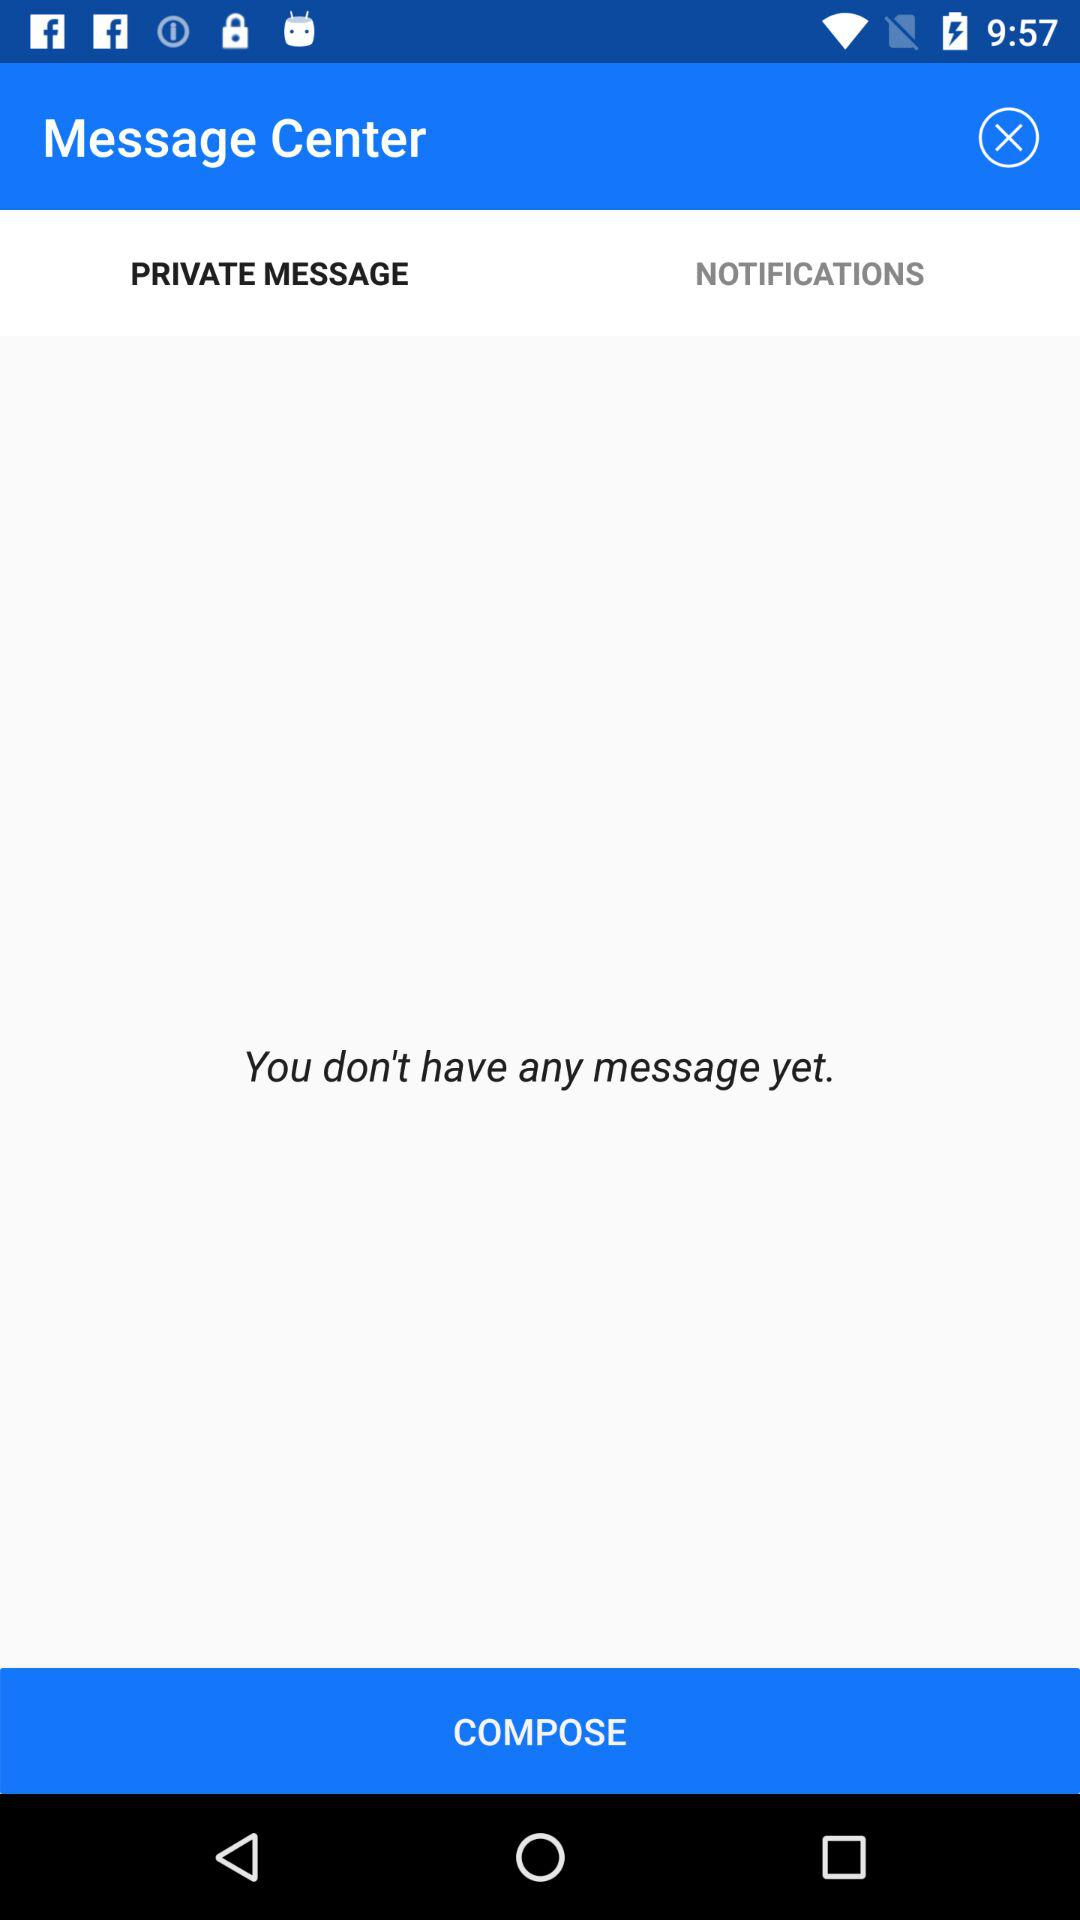How many messages do I have?
Answer the question using a single word or phrase. 0 